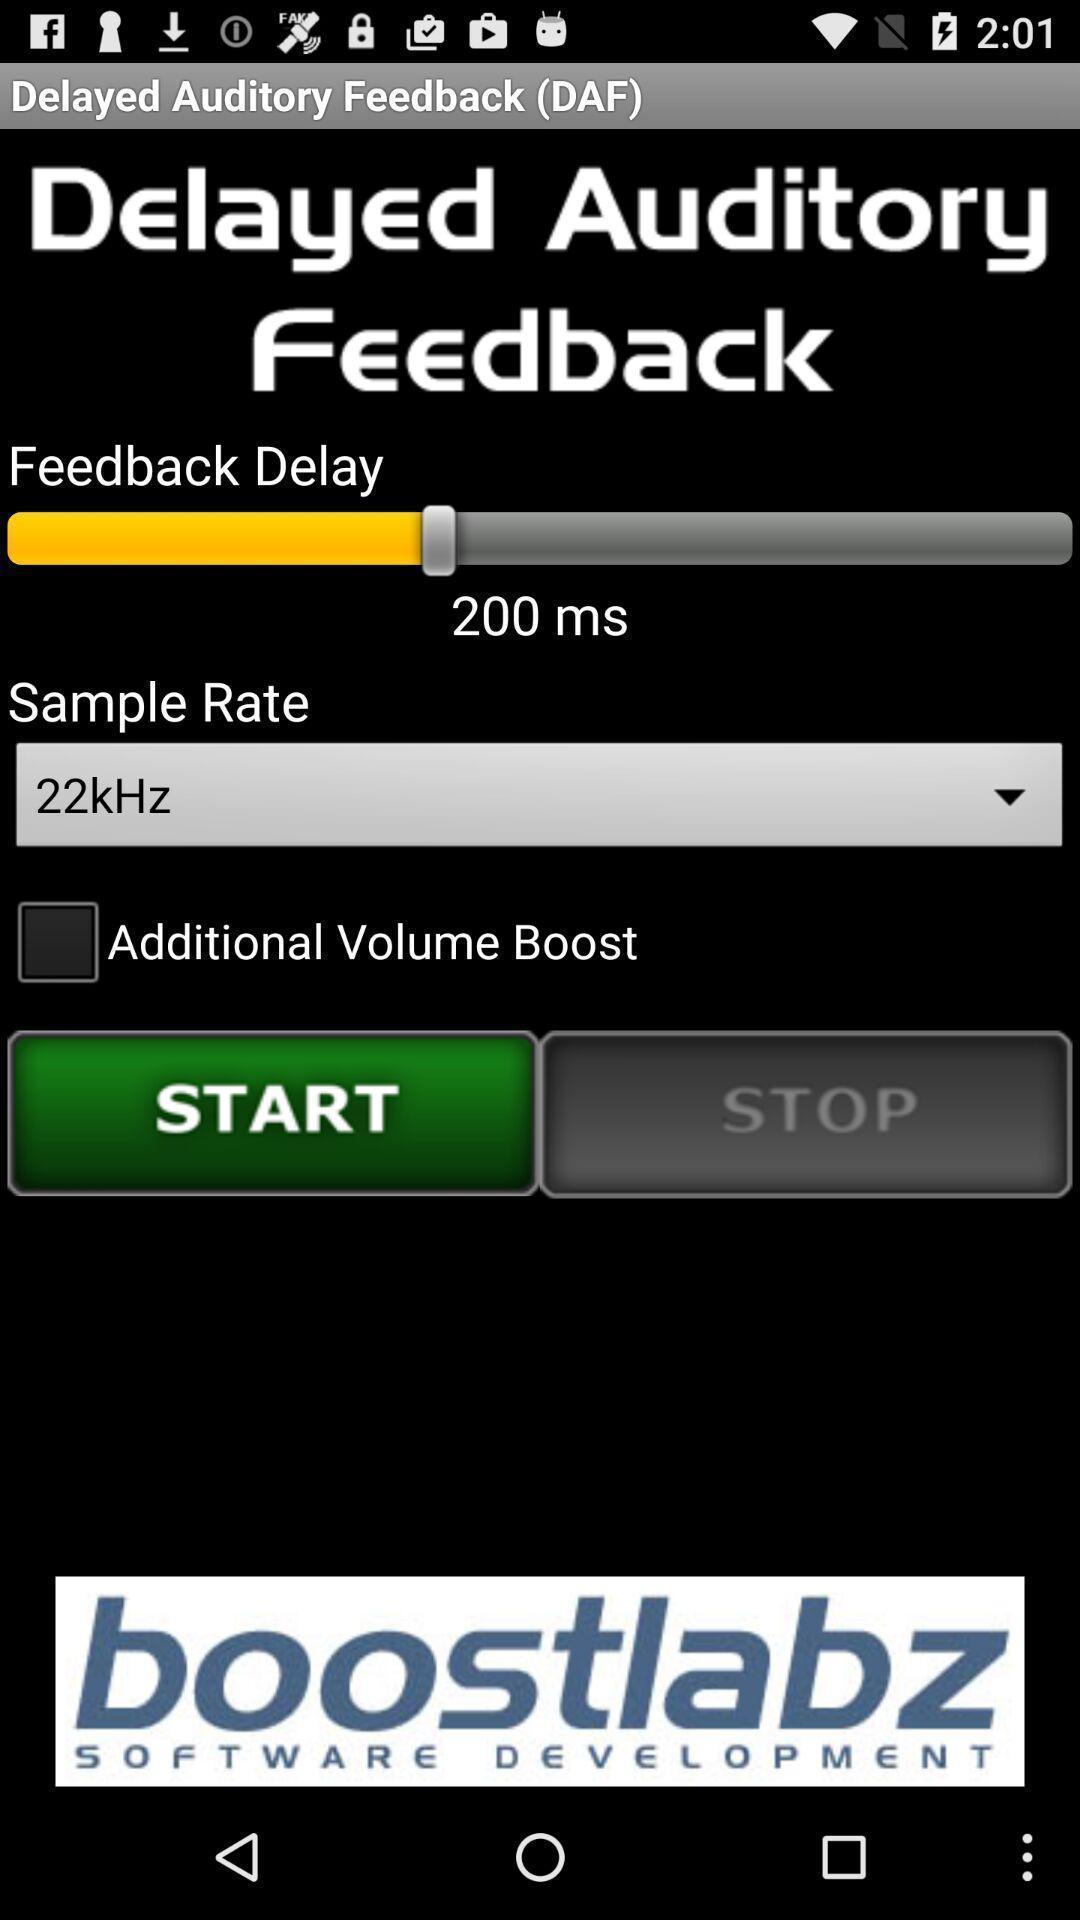Describe the key features of this screenshot. Welcome page for an application. 